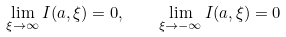<formula> <loc_0><loc_0><loc_500><loc_500>\lim _ { \xi \rightarrow \infty } I ( a , \xi ) = 0 , \quad \lim _ { \xi \rightarrow - \infty } I ( a , \xi ) = 0</formula> 